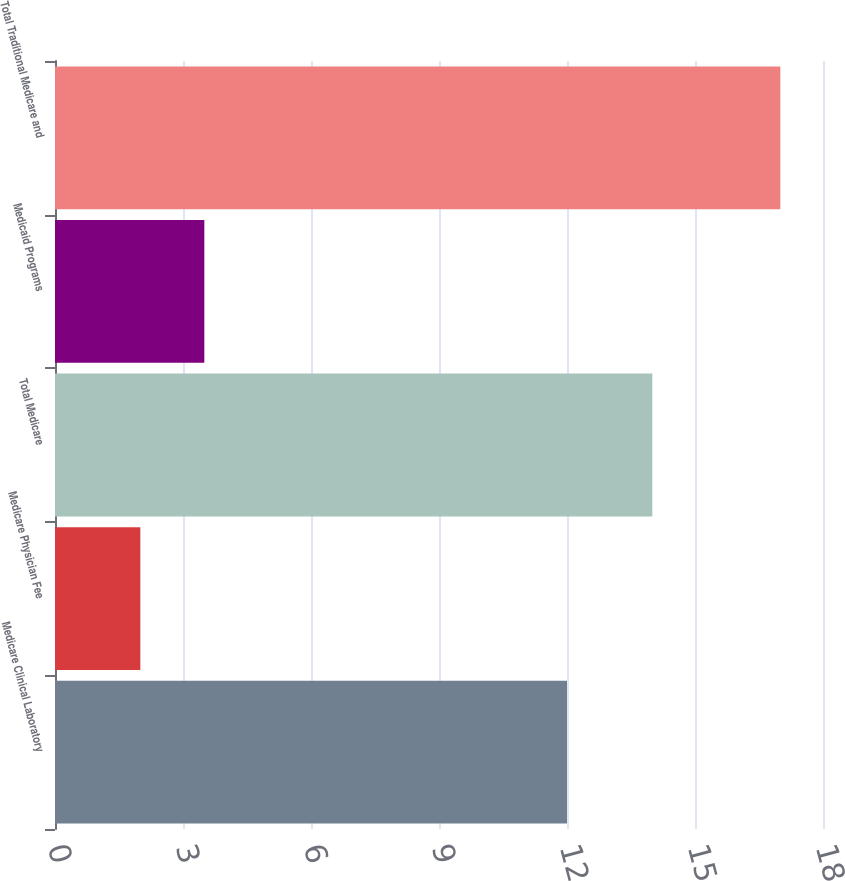<chart> <loc_0><loc_0><loc_500><loc_500><bar_chart><fcel>Medicare Clinical Laboratory<fcel>Medicare Physician Fee<fcel>Total Medicare<fcel>Medicaid Programs<fcel>Total Traditional Medicare and<nl><fcel>12<fcel>2<fcel>14<fcel>3.5<fcel>17<nl></chart> 